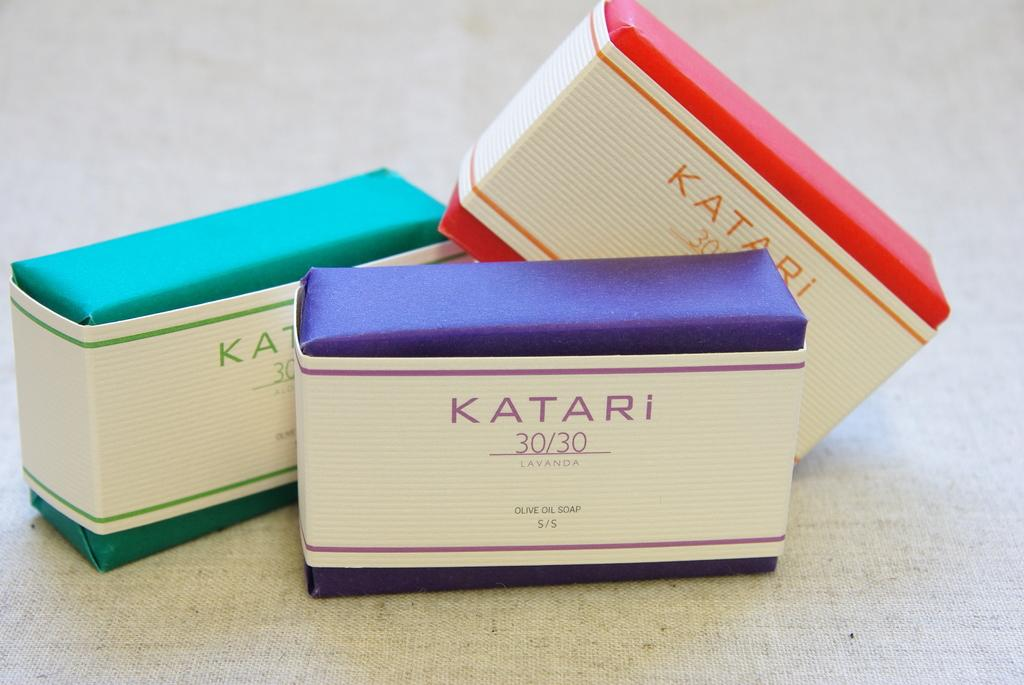Provide a one-sentence caption for the provided image. A stack of three colorful boxes of Katari 30/30. 